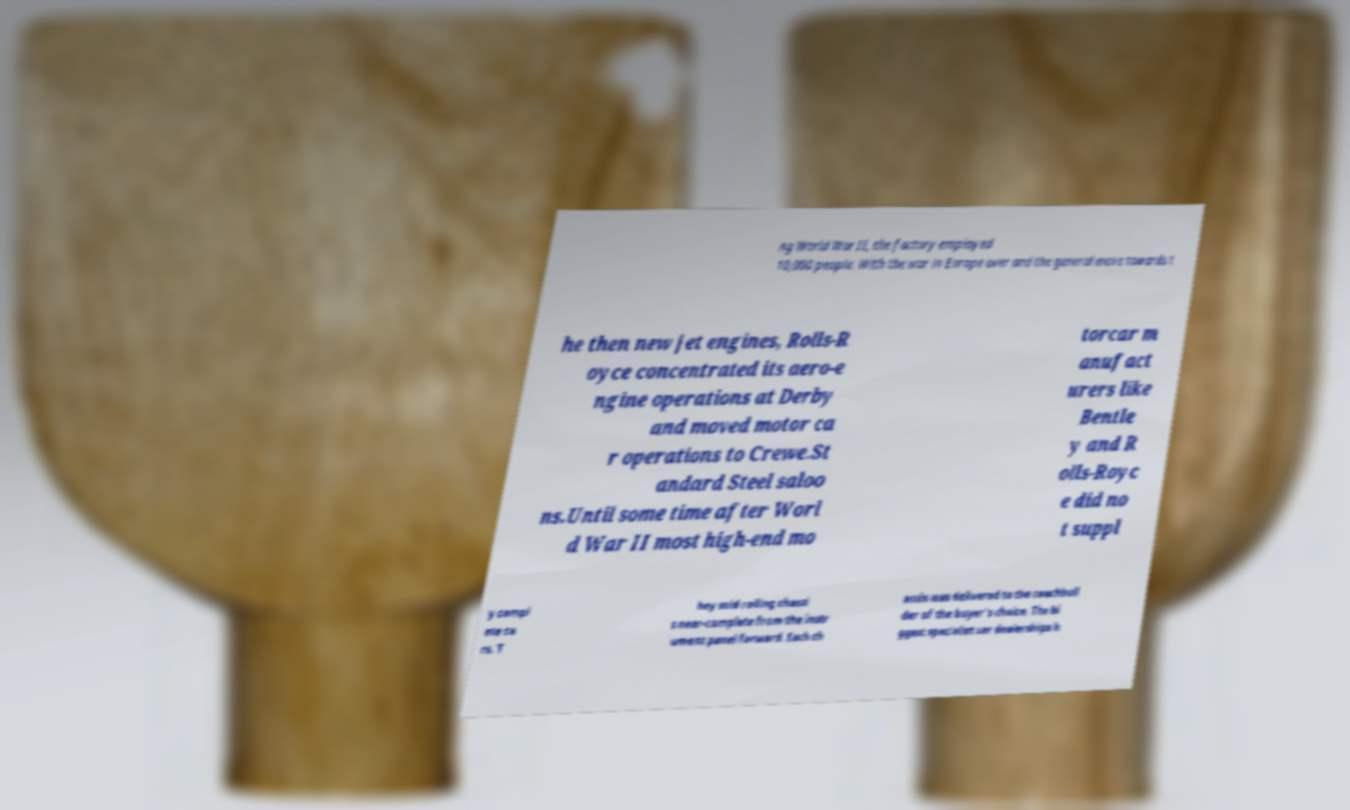Please identify and transcribe the text found in this image. ng World War II, the factory employed 10,000 people. With the war in Europe over and the general move towards t he then new jet engines, Rolls-R oyce concentrated its aero-e ngine operations at Derby and moved motor ca r operations to Crewe.St andard Steel saloo ns.Until some time after Worl d War II most high-end mo torcar m anufact urers like Bentle y and R olls-Royc e did no t suppl y compl ete ca rs. T hey sold rolling chassi s near-complete from the instr ument panel forward. Each ch assis was delivered to the coachbuil der of the buyer's choice. The bi ggest specialist car dealerships h 